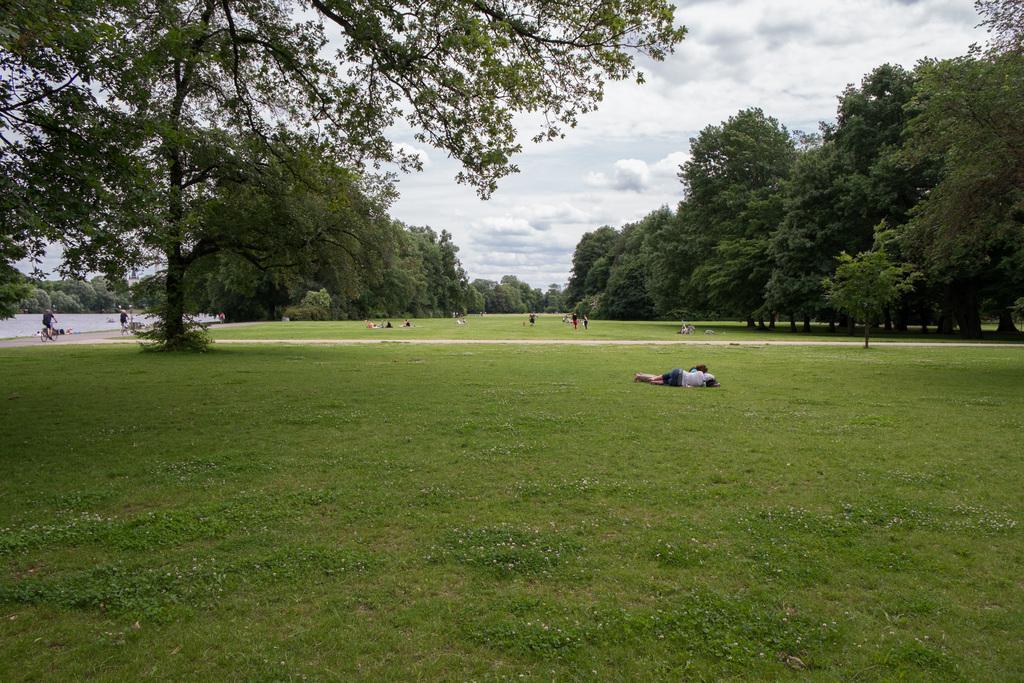Can you describe this image briefly? In this picture we can see group of people on the grass, in the background we can find few trees, water and clouds, on the left side of the image we can see a person is riding bicycle. 